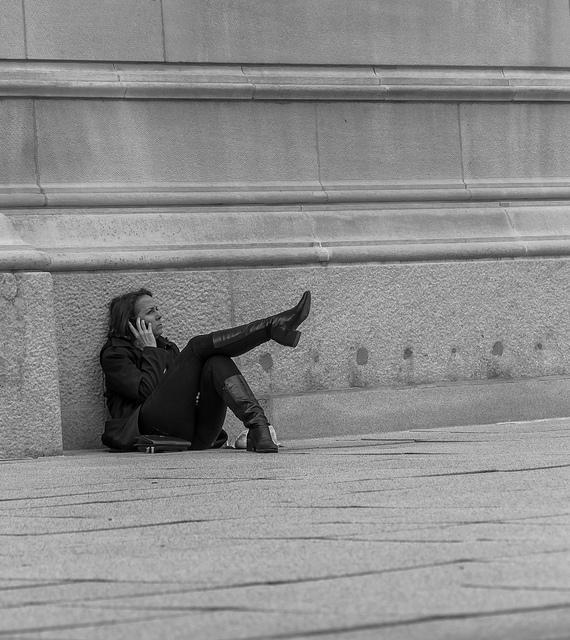How many people are there?
Give a very brief answer. 1. 